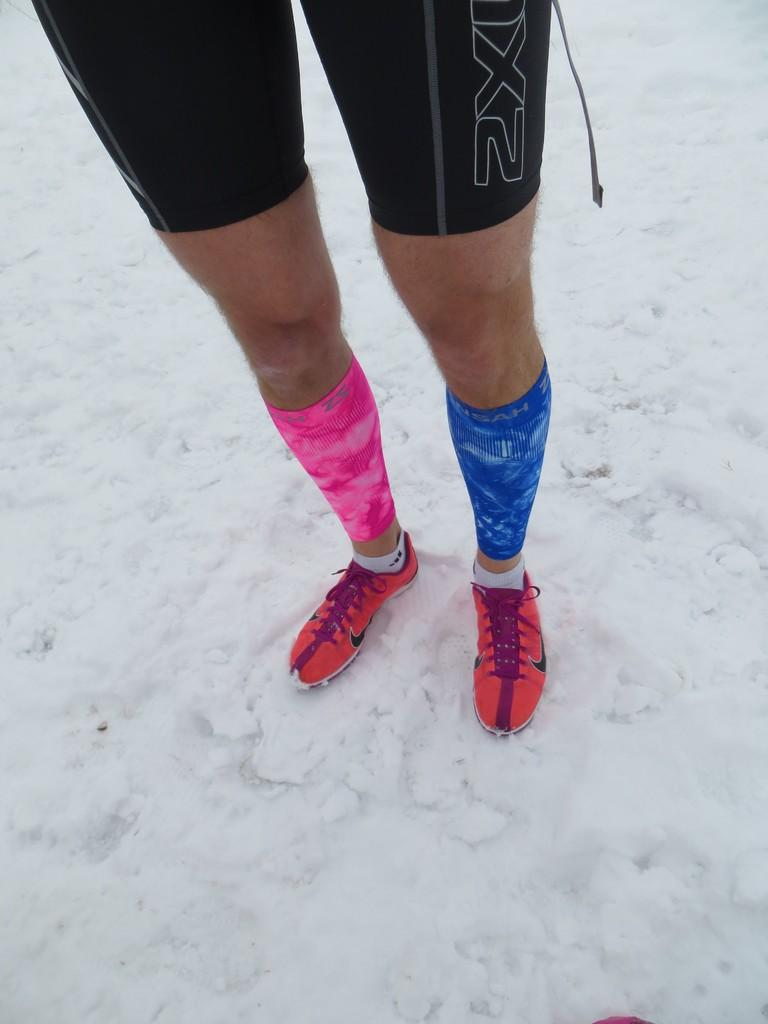What part of a person can be seen in the image? There are legs of a person visible in the image. What type of footwear is the person wearing? The person is wearing shoes. What distinguishing feature can be observed on the person's legs? The person has different color bands on their legs. What type of terrain is the person standing on? The person is standing on snow. What type of farm animals can be seen in the image? There are no farm animals present in the image. What emotion is the person feeling in the image, as indicated by the color bands on their legs? The color bands on the person's legs do not indicate any emotion; they are simply a distinguishing feature. 